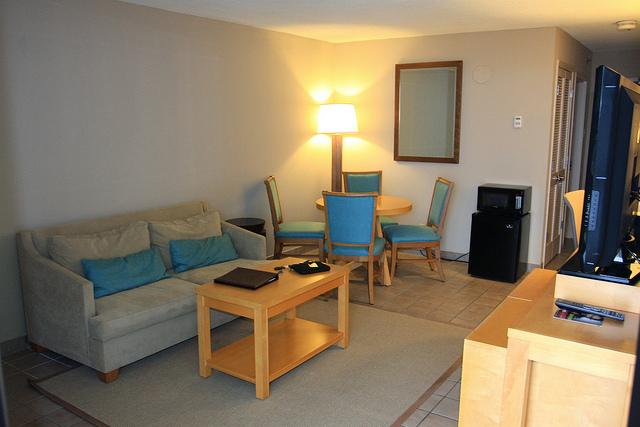How many chairs are in this picture?
Be succinct. 4. How many lights are on?
Keep it brief. 1. Is there a fireplace?
Write a very short answer. No. What color are the couch pillows?
Quick response, please. Blue. How many candles are on the table?
Quick response, please. 0. How many chairs are seen?
Answer briefly. 4. Is there an area rug in the room?
Keep it brief. Yes. Is this a big room or a little room?
Be succinct. Big. What is the t.v. sitting on?
Be succinct. Sideboard. What color is the sofa?
Be succinct. Gray. In inches, approximately how large are the floor tiles?
Be succinct. 10. Does this home have a pet?
Answer briefly. No. What color is the chair?
Answer briefly. Blue. Is this all one picture?
Write a very short answer. Yes. What color is the binder on the coffee table?
Concise answer only. Black. Is this room a living room?
Answer briefly. Yes. Where in the house was this photo taken?
Short answer required. Living room. What type of chair is in the image?
Give a very brief answer. Dining. What type of ceiling is this?
Write a very short answer. Painted. What color is the mantle?
Keep it brief. Brown. Is this a loft?
Quick response, please. No. 